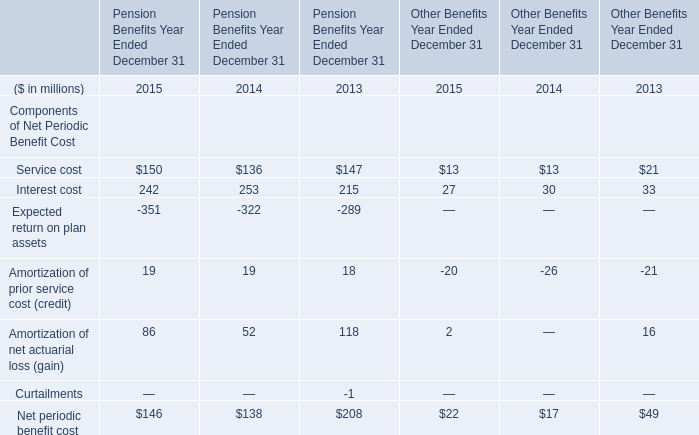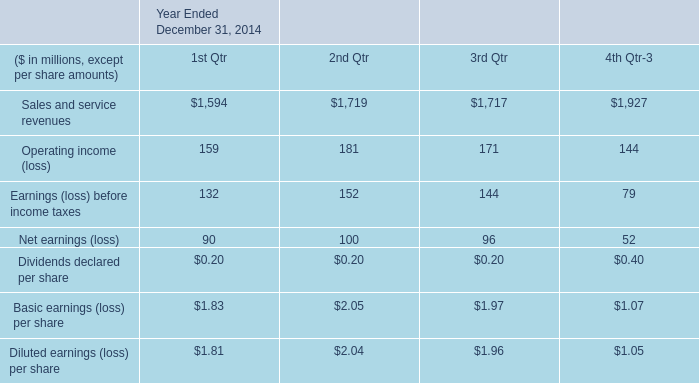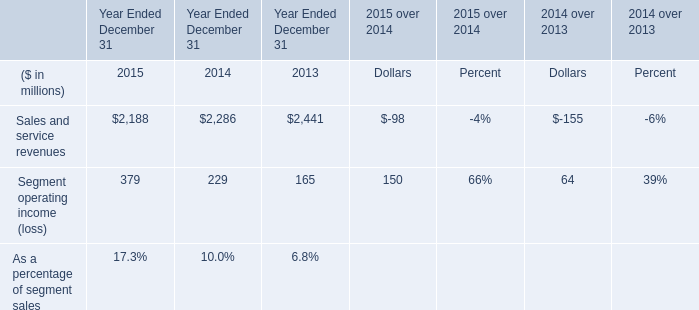What's the sum of all elements for Pension Benefits Year Ended December 31 that are greater than 100 in 2013? (in million) 
Computations: ((147 + 215) + 118)
Answer: 480.0. 